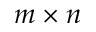<formula> <loc_0><loc_0><loc_500><loc_500>m \times n</formula> 